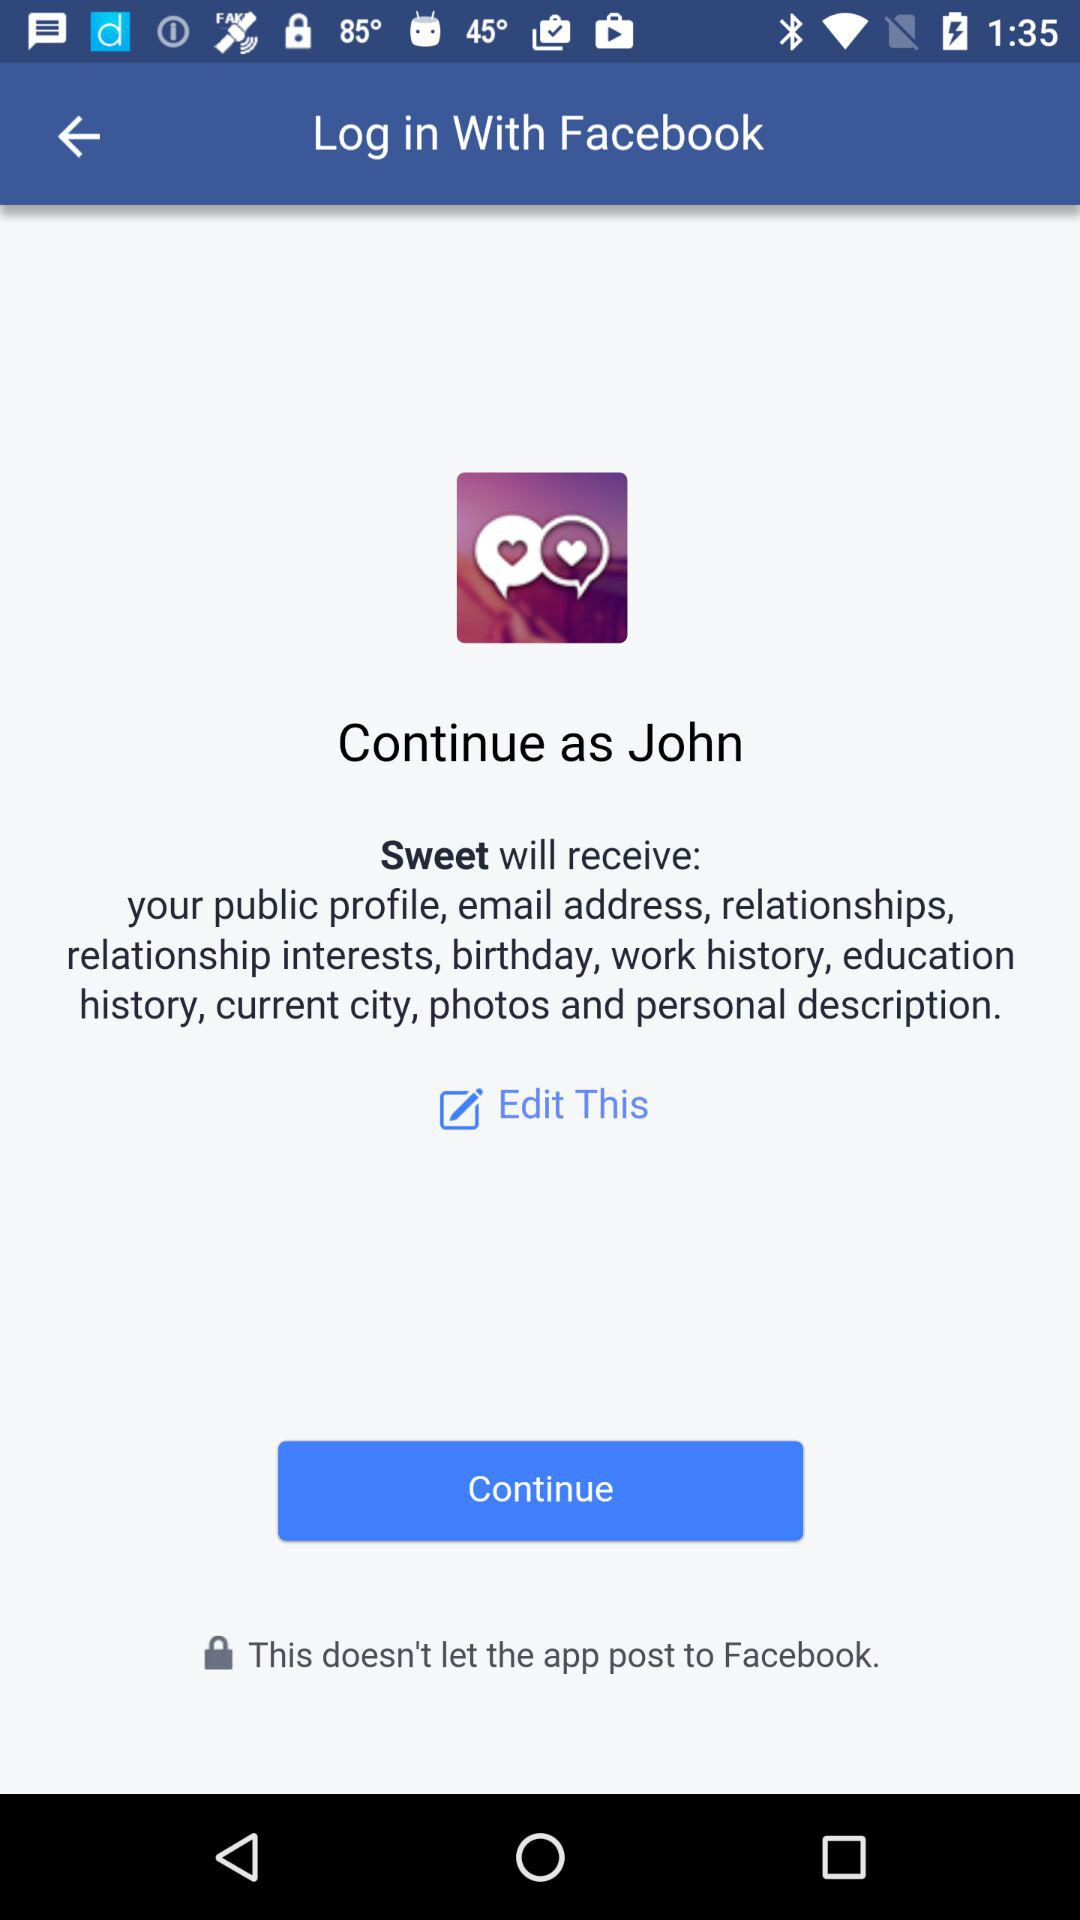Which version of the application is this?
When the provided information is insufficient, respond with <no answer>. <no answer> 